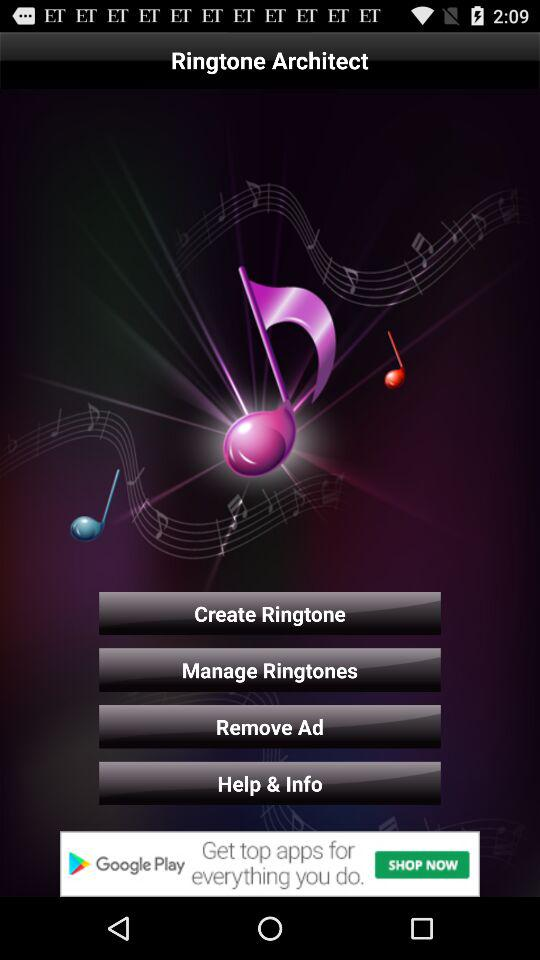What is the version number of "Rington Architect"?
When the provided information is insufficient, respond with <no answer>. <no answer> 